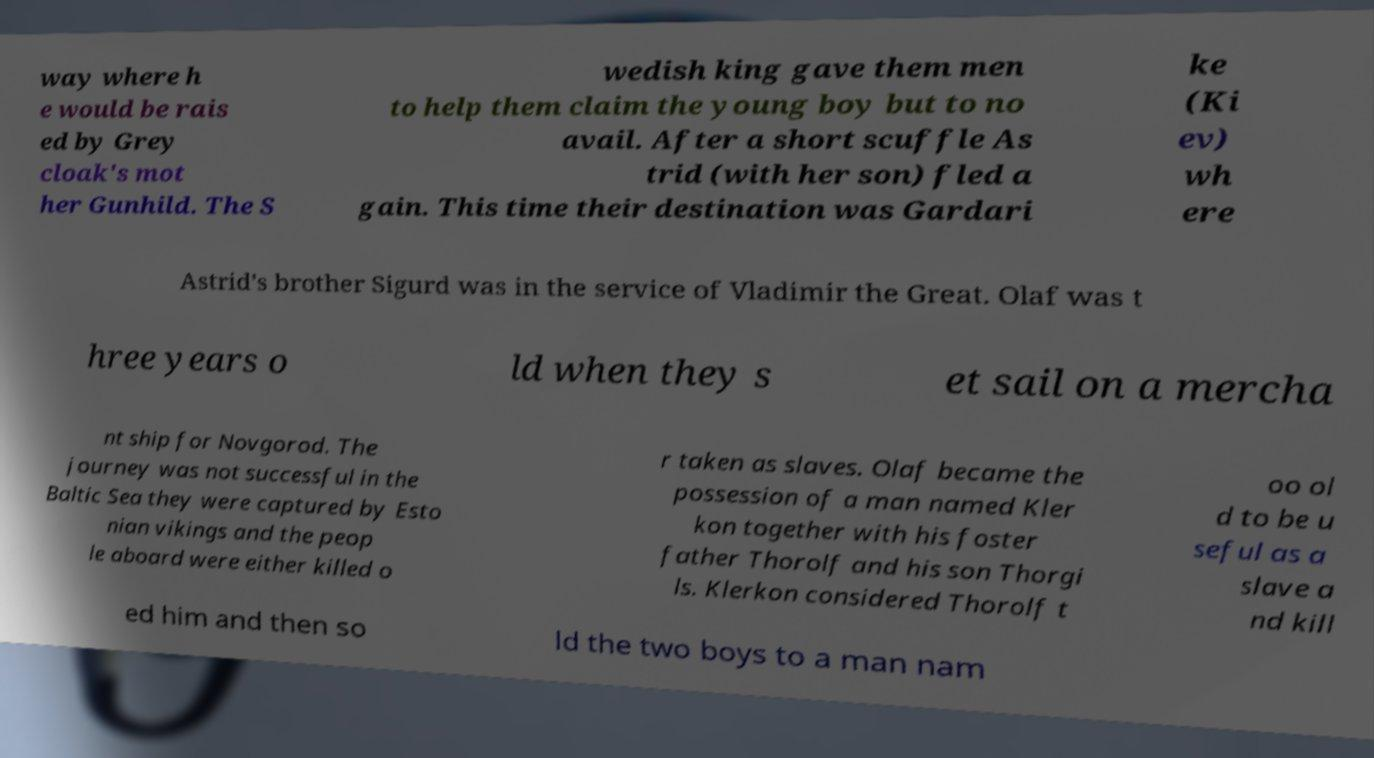There's text embedded in this image that I need extracted. Can you transcribe it verbatim? way where h e would be rais ed by Grey cloak's mot her Gunhild. The S wedish king gave them men to help them claim the young boy but to no avail. After a short scuffle As trid (with her son) fled a gain. This time their destination was Gardari ke (Ki ev) wh ere Astrid's brother Sigurd was in the service of Vladimir the Great. Olaf was t hree years o ld when they s et sail on a mercha nt ship for Novgorod. The journey was not successful in the Baltic Sea they were captured by Esto nian vikings and the peop le aboard were either killed o r taken as slaves. Olaf became the possession of a man named Kler kon together with his foster father Thorolf and his son Thorgi ls. Klerkon considered Thorolf t oo ol d to be u seful as a slave a nd kill ed him and then so ld the two boys to a man nam 